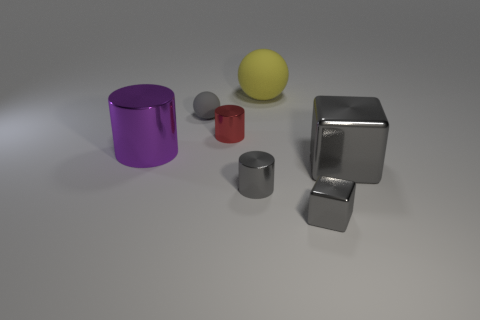What material is the small cylinder that is the same color as the small shiny cube?
Ensure brevity in your answer.  Metal. Is the red metallic cylinder the same size as the gray metal cylinder?
Offer a terse response. Yes. There is a matte thing that is to the right of the tiny gray cylinder; is there a large cylinder that is to the right of it?
Your answer should be compact. No. The other shiny block that is the same color as the small metallic block is what size?
Ensure brevity in your answer.  Large. What shape is the matte thing to the left of the big yellow matte ball?
Your answer should be very brief. Sphere. There is a large metal thing on the right side of the matte ball to the right of the gray cylinder; how many big matte objects are left of it?
Give a very brief answer. 1. Does the red metal thing have the same size as the gray shiny object left of the tiny gray metallic block?
Provide a succinct answer. Yes. How big is the metallic thing in front of the small cylinder that is in front of the big gray thing?
Ensure brevity in your answer.  Small. How many big gray objects have the same material as the gray cylinder?
Make the answer very short. 1. Are any big gray metallic things visible?
Provide a succinct answer. Yes. 